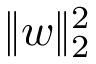Convert formula to latex. <formula><loc_0><loc_0><loc_500><loc_500>\| w \| _ { 2 } ^ { 2 }</formula> 